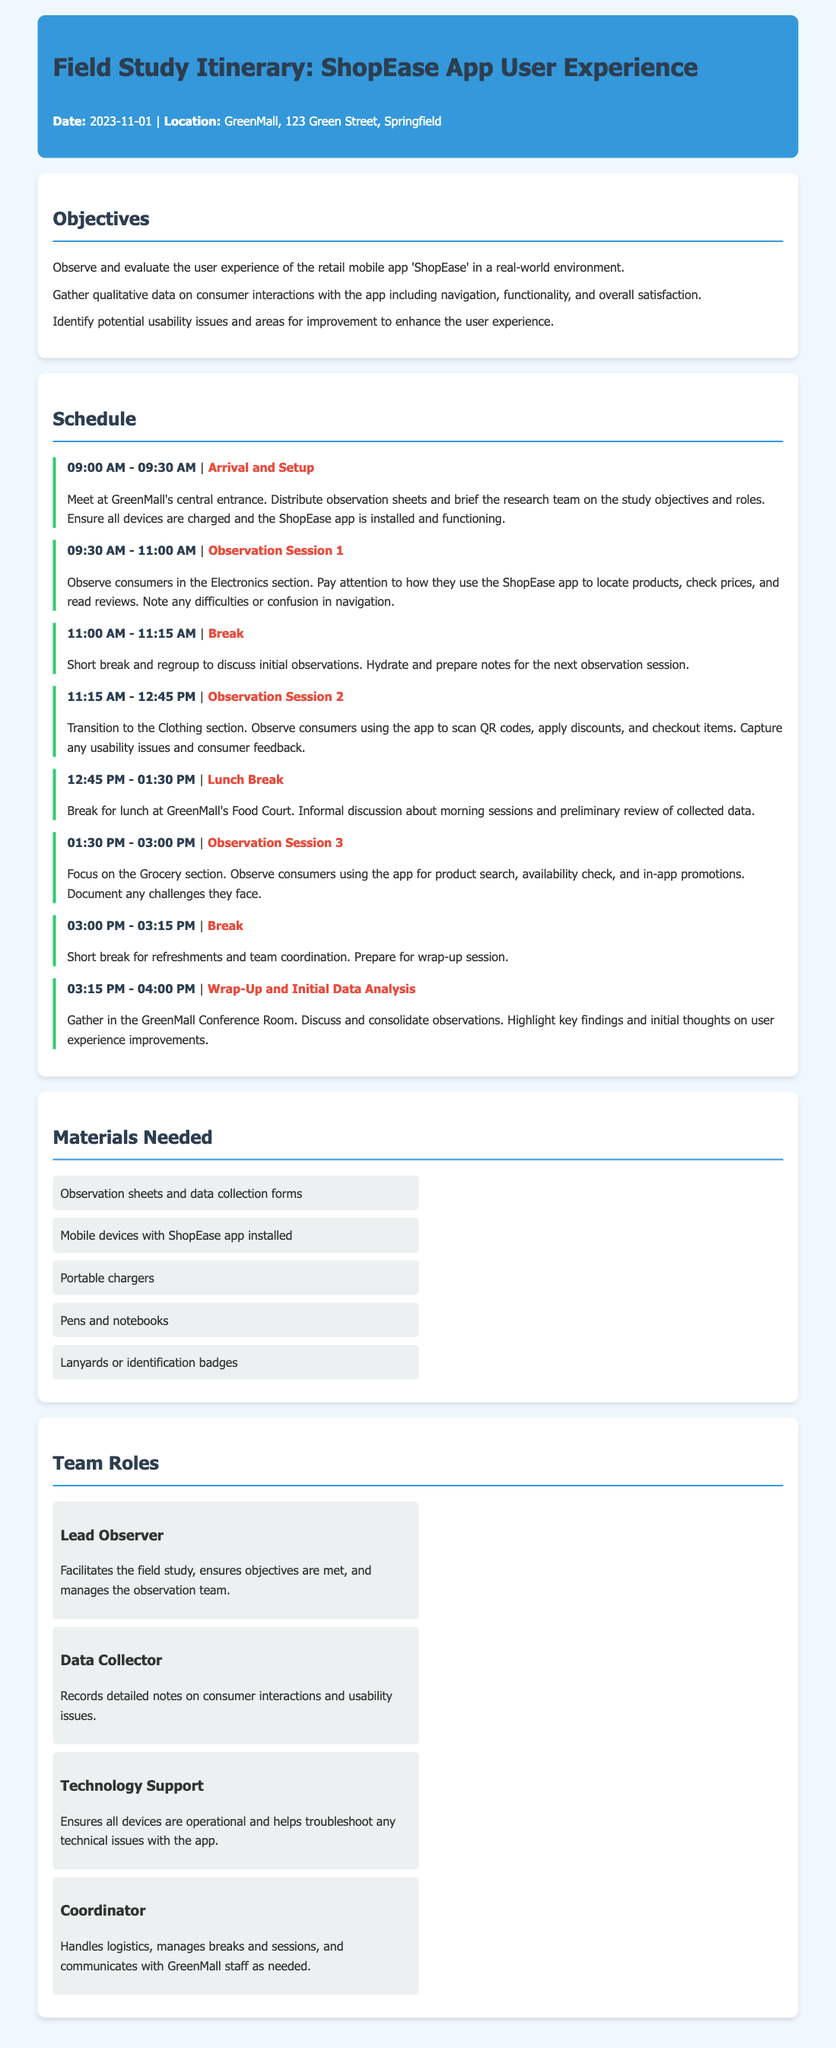what is the date of the field study? The date of the field study is specified in the header of the document.
Answer: 2023-11-01 where will the field study take place? The location of the field study is mentioned in the header of the document.
Answer: GreenMall, 123 Green Street, Springfield what is the first activity listed in the schedule? The first activity is noted in the schedule section of the document.
Answer: Arrival and Setup how long is the lunch break? The duration of the lunch break is described in the schedule section.
Answer: 45 minutes who is responsible for managing the observation team? The role responsible for this task is mentioned in the team roles section.
Answer: Lead Observer what is one key objective of the field study? The objectives of the field study are listed in the objectives section.
Answer: Observe and evaluate the user experience of the retail mobile app 'ShopEase' how many observation sessions are scheduled? The number of observation sessions can be counted from the schedule section of the document.
Answer: Three sessions what type of materials are needed for the study? The materials needed are outlined in a dedicated section of the document.
Answer: Observation sheets and data collection forms who handles logistics and communication with staff? The role in charge of these tasks is specified in the team roles section.
Answer: Coordinator 